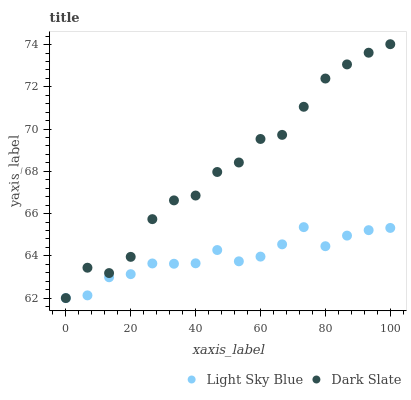Does Light Sky Blue have the minimum area under the curve?
Answer yes or no. Yes. Does Dark Slate have the maximum area under the curve?
Answer yes or no. Yes. Does Light Sky Blue have the maximum area under the curve?
Answer yes or no. No. Is Light Sky Blue the smoothest?
Answer yes or no. Yes. Is Dark Slate the roughest?
Answer yes or no. Yes. Is Light Sky Blue the roughest?
Answer yes or no. No. Does Dark Slate have the lowest value?
Answer yes or no. Yes. Does Dark Slate have the highest value?
Answer yes or no. Yes. Does Light Sky Blue have the highest value?
Answer yes or no. No. Does Light Sky Blue intersect Dark Slate?
Answer yes or no. Yes. Is Light Sky Blue less than Dark Slate?
Answer yes or no. No. Is Light Sky Blue greater than Dark Slate?
Answer yes or no. No. 